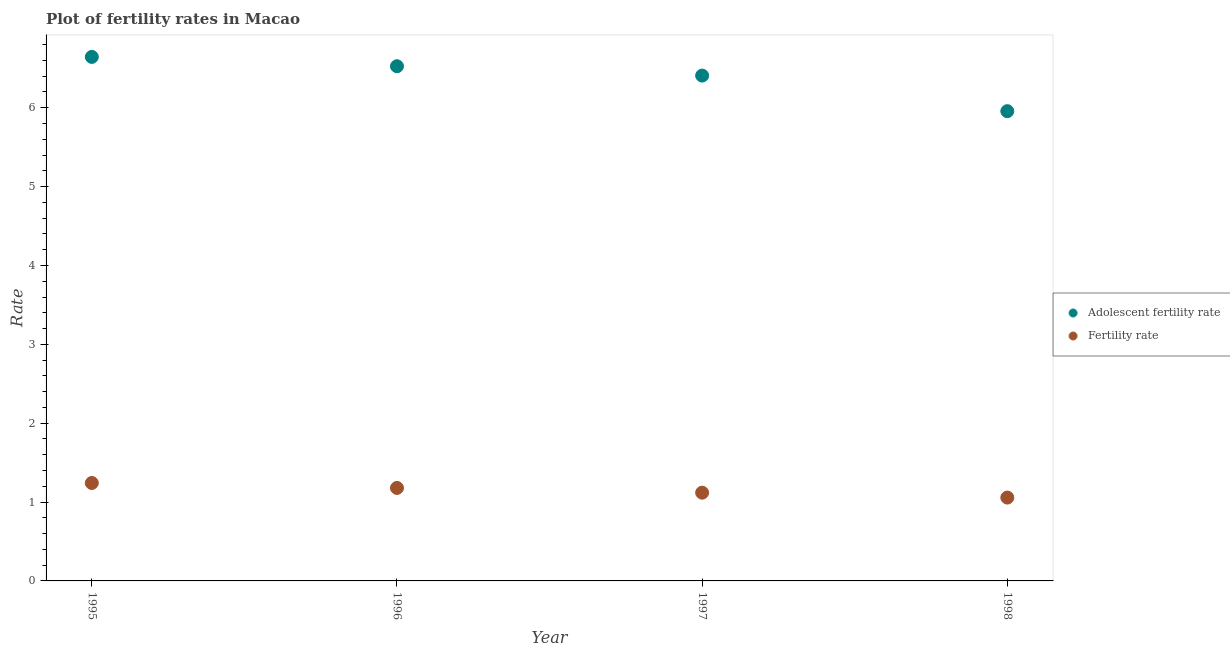Is the number of dotlines equal to the number of legend labels?
Your response must be concise. Yes. What is the adolescent fertility rate in 1996?
Provide a succinct answer. 6.53. Across all years, what is the maximum fertility rate?
Ensure brevity in your answer.  1.24. Across all years, what is the minimum fertility rate?
Your answer should be compact. 1.06. In which year was the fertility rate maximum?
Offer a terse response. 1995. What is the total adolescent fertility rate in the graph?
Provide a short and direct response. 25.54. What is the difference between the adolescent fertility rate in 1995 and that in 1997?
Your answer should be very brief. 0.24. What is the difference between the adolescent fertility rate in 1997 and the fertility rate in 1995?
Keep it short and to the point. 5.17. What is the average adolescent fertility rate per year?
Offer a terse response. 6.38. In the year 1997, what is the difference between the fertility rate and adolescent fertility rate?
Offer a terse response. -5.29. In how many years, is the fertility rate greater than 3.6?
Your response must be concise. 0. What is the ratio of the fertility rate in 1995 to that in 1996?
Keep it short and to the point. 1.05. What is the difference between the highest and the second highest fertility rate?
Ensure brevity in your answer.  0.06. What is the difference between the highest and the lowest adolescent fertility rate?
Your answer should be very brief. 0.69. In how many years, is the fertility rate greater than the average fertility rate taken over all years?
Give a very brief answer. 2. Is the sum of the adolescent fertility rate in 1997 and 1998 greater than the maximum fertility rate across all years?
Give a very brief answer. Yes. Does the adolescent fertility rate monotonically increase over the years?
Keep it short and to the point. No. How many dotlines are there?
Give a very brief answer. 2. How many years are there in the graph?
Offer a terse response. 4. What is the difference between two consecutive major ticks on the Y-axis?
Keep it short and to the point. 1. Does the graph contain grids?
Keep it short and to the point. No. How many legend labels are there?
Provide a succinct answer. 2. What is the title of the graph?
Your response must be concise. Plot of fertility rates in Macao. Does "Largest city" appear as one of the legend labels in the graph?
Ensure brevity in your answer.  No. What is the label or title of the X-axis?
Keep it short and to the point. Year. What is the label or title of the Y-axis?
Your response must be concise. Rate. What is the Rate of Adolescent fertility rate in 1995?
Your response must be concise. 6.64. What is the Rate in Fertility rate in 1995?
Make the answer very short. 1.24. What is the Rate in Adolescent fertility rate in 1996?
Offer a very short reply. 6.53. What is the Rate of Fertility rate in 1996?
Your answer should be very brief. 1.18. What is the Rate of Adolescent fertility rate in 1997?
Keep it short and to the point. 6.41. What is the Rate in Fertility rate in 1997?
Offer a terse response. 1.12. What is the Rate in Adolescent fertility rate in 1998?
Your answer should be compact. 5.96. What is the Rate in Fertility rate in 1998?
Give a very brief answer. 1.06. Across all years, what is the maximum Rate of Adolescent fertility rate?
Your answer should be compact. 6.64. Across all years, what is the maximum Rate in Fertility rate?
Offer a terse response. 1.24. Across all years, what is the minimum Rate of Adolescent fertility rate?
Give a very brief answer. 5.96. Across all years, what is the minimum Rate in Fertility rate?
Ensure brevity in your answer.  1.06. What is the total Rate in Adolescent fertility rate in the graph?
Ensure brevity in your answer.  25.54. What is the total Rate in Fertility rate in the graph?
Your answer should be compact. 4.6. What is the difference between the Rate of Adolescent fertility rate in 1995 and that in 1996?
Your answer should be compact. 0.12. What is the difference between the Rate of Fertility rate in 1995 and that in 1996?
Your answer should be compact. 0.06. What is the difference between the Rate in Adolescent fertility rate in 1995 and that in 1997?
Give a very brief answer. 0.24. What is the difference between the Rate of Fertility rate in 1995 and that in 1997?
Your response must be concise. 0.12. What is the difference between the Rate in Adolescent fertility rate in 1995 and that in 1998?
Keep it short and to the point. 0.69. What is the difference between the Rate in Fertility rate in 1995 and that in 1998?
Offer a terse response. 0.18. What is the difference between the Rate in Adolescent fertility rate in 1996 and that in 1997?
Ensure brevity in your answer.  0.12. What is the difference between the Rate in Adolescent fertility rate in 1996 and that in 1998?
Your response must be concise. 0.57. What is the difference between the Rate of Fertility rate in 1996 and that in 1998?
Offer a terse response. 0.12. What is the difference between the Rate of Adolescent fertility rate in 1997 and that in 1998?
Offer a very short reply. 0.45. What is the difference between the Rate in Fertility rate in 1997 and that in 1998?
Offer a very short reply. 0.06. What is the difference between the Rate in Adolescent fertility rate in 1995 and the Rate in Fertility rate in 1996?
Your response must be concise. 5.47. What is the difference between the Rate in Adolescent fertility rate in 1995 and the Rate in Fertility rate in 1997?
Provide a short and direct response. 5.53. What is the difference between the Rate of Adolescent fertility rate in 1995 and the Rate of Fertility rate in 1998?
Make the answer very short. 5.59. What is the difference between the Rate of Adolescent fertility rate in 1996 and the Rate of Fertility rate in 1997?
Provide a short and direct response. 5.41. What is the difference between the Rate in Adolescent fertility rate in 1996 and the Rate in Fertility rate in 1998?
Make the answer very short. 5.47. What is the difference between the Rate of Adolescent fertility rate in 1997 and the Rate of Fertility rate in 1998?
Offer a very short reply. 5.35. What is the average Rate in Adolescent fertility rate per year?
Offer a very short reply. 6.38. What is the average Rate in Fertility rate per year?
Your answer should be very brief. 1.15. In the year 1995, what is the difference between the Rate in Adolescent fertility rate and Rate in Fertility rate?
Make the answer very short. 5.4. In the year 1996, what is the difference between the Rate of Adolescent fertility rate and Rate of Fertility rate?
Ensure brevity in your answer.  5.35. In the year 1997, what is the difference between the Rate of Adolescent fertility rate and Rate of Fertility rate?
Your answer should be compact. 5.29. In the year 1998, what is the difference between the Rate of Adolescent fertility rate and Rate of Fertility rate?
Your response must be concise. 4.9. What is the ratio of the Rate of Adolescent fertility rate in 1995 to that in 1996?
Your answer should be very brief. 1.02. What is the ratio of the Rate in Fertility rate in 1995 to that in 1996?
Make the answer very short. 1.05. What is the ratio of the Rate in Adolescent fertility rate in 1995 to that in 1997?
Your answer should be very brief. 1.04. What is the ratio of the Rate of Fertility rate in 1995 to that in 1997?
Offer a terse response. 1.11. What is the ratio of the Rate in Adolescent fertility rate in 1995 to that in 1998?
Offer a very short reply. 1.12. What is the ratio of the Rate in Fertility rate in 1995 to that in 1998?
Give a very brief answer. 1.18. What is the ratio of the Rate in Adolescent fertility rate in 1996 to that in 1997?
Offer a very short reply. 1.02. What is the ratio of the Rate in Fertility rate in 1996 to that in 1997?
Keep it short and to the point. 1.05. What is the ratio of the Rate in Adolescent fertility rate in 1996 to that in 1998?
Your answer should be compact. 1.1. What is the ratio of the Rate in Fertility rate in 1996 to that in 1998?
Your response must be concise. 1.12. What is the ratio of the Rate in Adolescent fertility rate in 1997 to that in 1998?
Make the answer very short. 1.08. What is the ratio of the Rate in Fertility rate in 1997 to that in 1998?
Offer a terse response. 1.06. What is the difference between the highest and the second highest Rate of Adolescent fertility rate?
Keep it short and to the point. 0.12. What is the difference between the highest and the second highest Rate of Fertility rate?
Offer a terse response. 0.06. What is the difference between the highest and the lowest Rate of Adolescent fertility rate?
Offer a terse response. 0.69. What is the difference between the highest and the lowest Rate in Fertility rate?
Give a very brief answer. 0.18. 